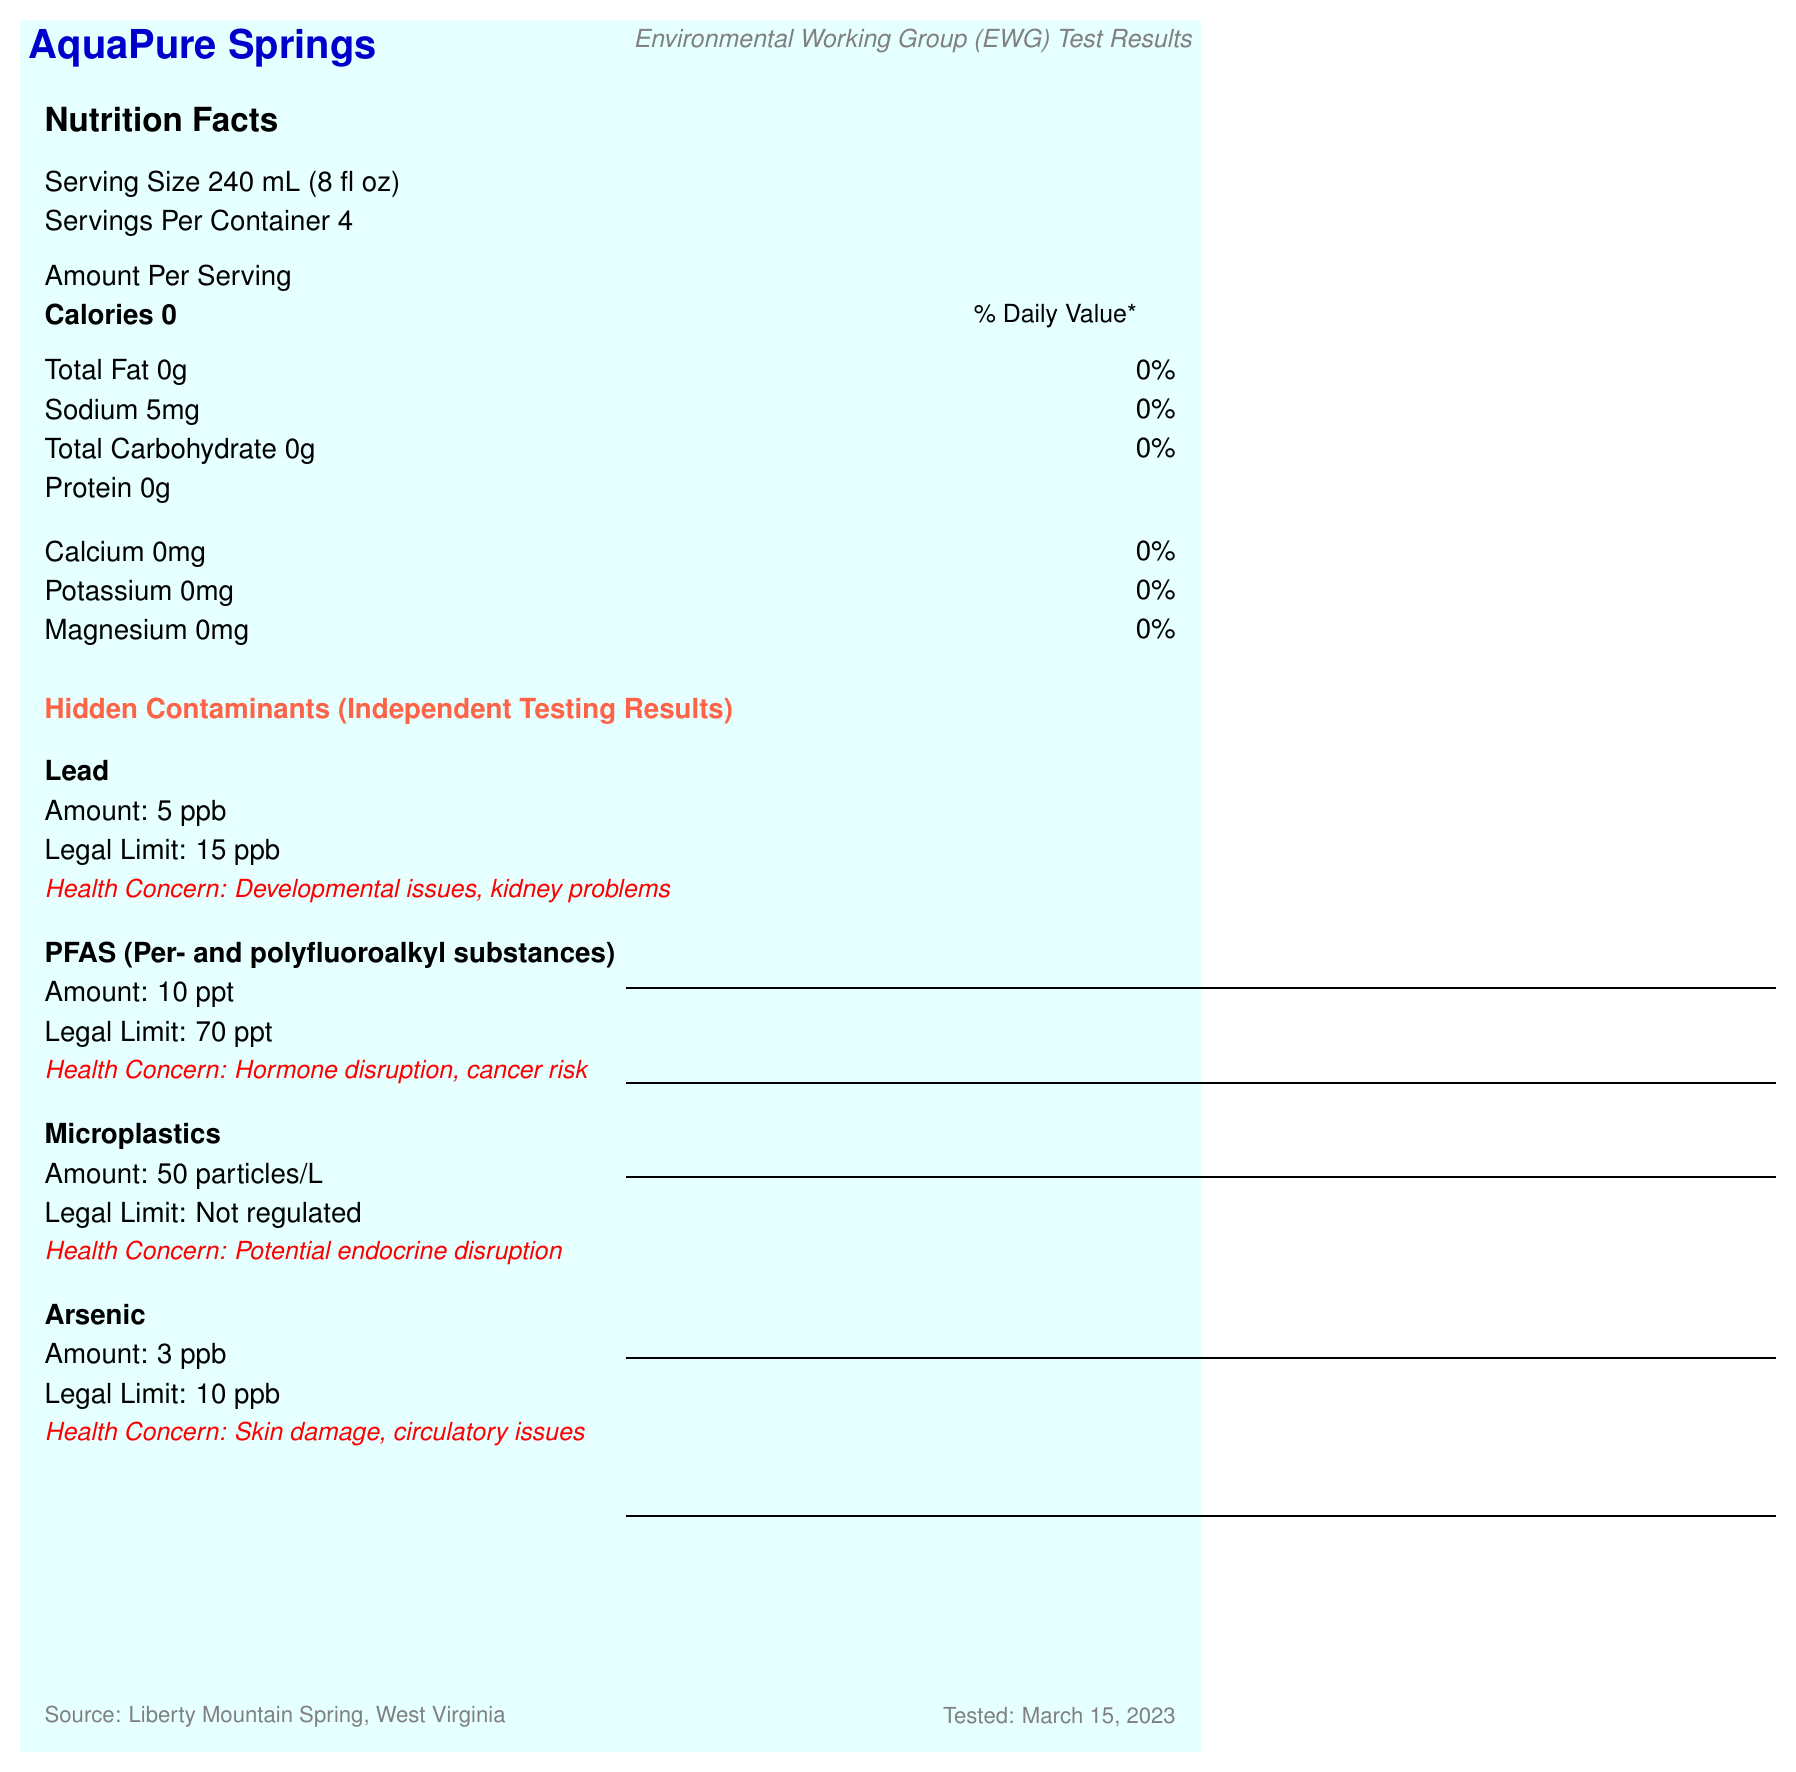what is the serving size? The serving size is clearly stated in the "Nutrition Facts" section of the document.
Answer: 240 mL (8 fl oz) How many servings are in the container? The document lists the "Servings Per Container" as 4.
Answer: 4 What is the source of AquaPure Springs bottled water? The source information is given at the bottom of the document.
Answer: Liberty Mountain Spring, West Virginia What is the sodium content per serving? The sodium content is listed in the nutritional information as "Sodium 5mg."
Answer: 5 mg What is the calcium content per serving according to the label? The nutritional information specifies "Calcium 0mg."
Answer: 0 mg How much lead is found in the water according to the independent test? The independent test results list the amount of lead as 5 ppb.
Answer: 5 ppb Which laboratory conducted the independent testing? The independent testing was conducted by the Environmental Working Group (EWG), as noted in the document.
Answer: Environmental Working Group (EWG) When was the independent testing conducted? The testing date is specified at the bottom of the document.
Answer: March 15, 2023 How much PFAS was detected in the water during the testing? The document lists PFAS levels as 10 ppt in the independent testing results.
Answer: 10 ppt What potential health concerns are associated with microplastics according to the document? A. Hormone disruption B. Skin damage C. Kidney problems D. Potential endocrine disruption The health concern associated with microplastics is listed as "Potential endocrine disruption."
Answer: D What is the legal limit for arsenic in drinking water? A. 5 ppb B. 10 ppb C. 15 ppb D. 50 ppb The legal limit for arsenic is 10 ppb, as stated in the document.
Answer: B Does the document mention FDA regulation of AquaPure Springs bottled water? It states in the regulatory compliance section that the water is FDA regulated.
Answer: Yes Does the document specify the exact type of microplastics in the water? The document only mentions the presence of microplastics and their amount, not the specific types.
Answer: No What is the main idea of the document? The document includes nutritional information, contaminant levels, source information, and independent testing results that highlight potential health problems associated with contaminants like lead, PFAS, microplastics, and arsenic.
Answer: The document presents the Nutrition Facts for AquaPure Springs bottled water along with independent test results showing the presence of various contaminants, which raise concerns about long-term consumption despite the water meeting legal standards. Is the treatment process mentioned in the document? The document states that the water undergoes reverse osmosis and UV sterilization.
Answer: Yes 